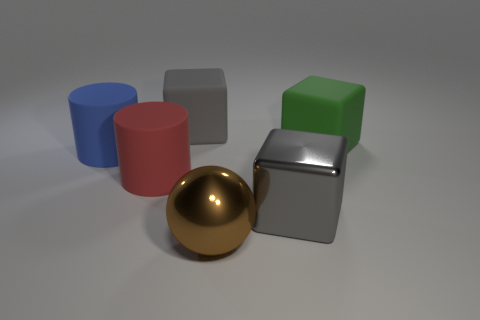Subtract all big green blocks. How many blocks are left? 2 Subtract all spheres. How many objects are left? 5 Add 4 gray cubes. How many gray cubes are left? 6 Add 2 green rubber objects. How many green rubber objects exist? 3 Add 3 large brown metallic things. How many objects exist? 9 Subtract all gray blocks. How many blocks are left? 1 Subtract 0 green spheres. How many objects are left? 6 Subtract 2 blocks. How many blocks are left? 1 Subtract all green cubes. Subtract all brown cylinders. How many cubes are left? 2 Subtract all gray cubes. How many cyan balls are left? 0 